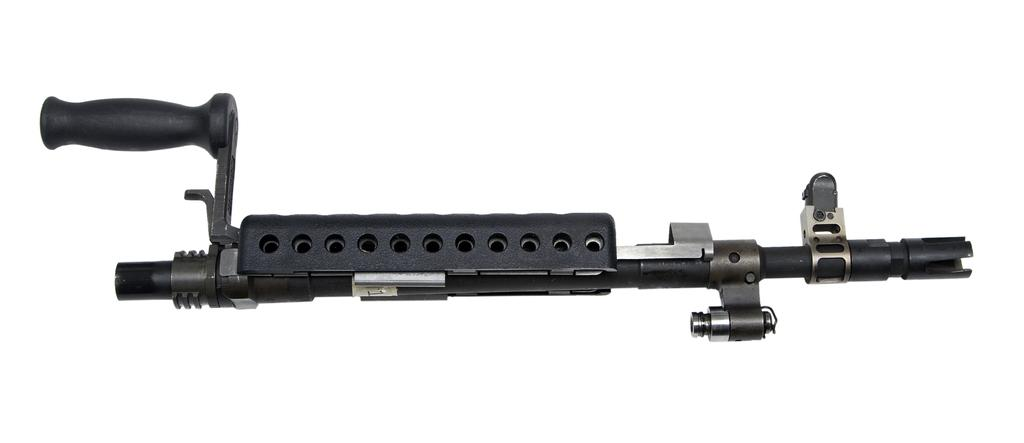What is the main object in the image? There is a gun in the image. What color is the background of the image? The background of the image is white. How many hens are visible in the image? There are no hens present in the image. What type of door is featured in the image? There is no door present in the image. 